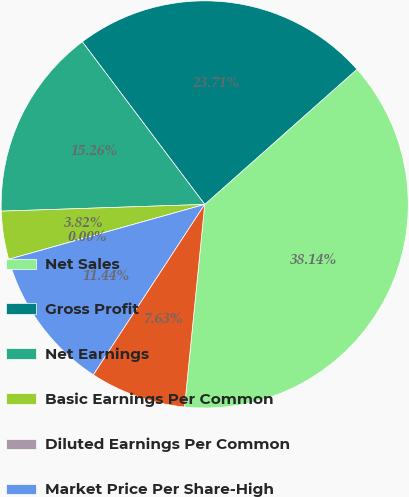Convert chart. <chart><loc_0><loc_0><loc_500><loc_500><pie_chart><fcel>Net Sales<fcel>Gross Profit<fcel>Net Earnings<fcel>Basic Earnings Per Common<fcel>Diluted Earnings Per Common<fcel>Market Price Per Share-High<fcel>Market Price Per Share-Low<nl><fcel>38.14%<fcel>23.71%<fcel>15.26%<fcel>3.82%<fcel>0.0%<fcel>11.44%<fcel>7.63%<nl></chart> 